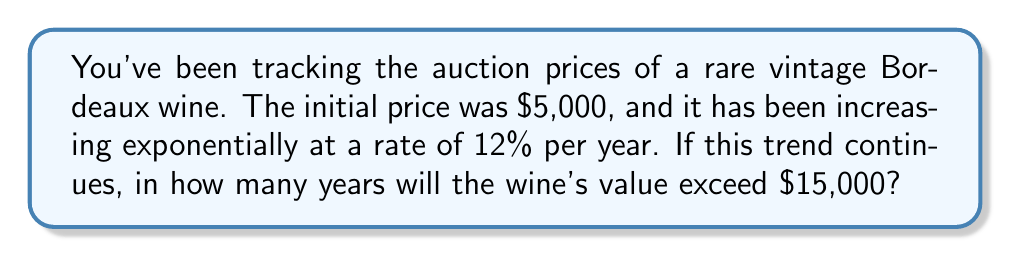Help me with this question. Let's approach this step-by-step using an exponential function:

1) The exponential function for this scenario is:
   $P(t) = 5000(1.12)^t$
   Where $P(t)$ is the price after $t$ years, $5000 is the initial price, and $1.12$ represents the 12% annual increase.

2) We want to find when $P(t)$ exceeds $15000:
   $15000 < 5000(1.12)^t$

3) Divide both sides by 5000:
   $3 < (1.12)^t$

4) Take the natural log of both sides:
   $\ln(3) < \ln((1.12)^t)$

5) Use the logarithm property $\ln(a^b) = b\ln(a)$:
   $\ln(3) < t\ln(1.12)$

6) Solve for $t$:
   $t > \frac{\ln(3)}{\ln(1.12)} \approx 9.96$

7) Since we're looking for the number of years, which must be a whole number, and we want to exceed $15000, we round up to the next integer.
Answer: 10 years 